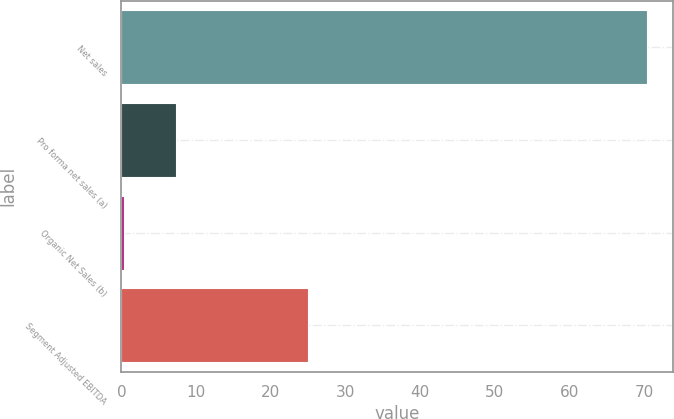Convert chart. <chart><loc_0><loc_0><loc_500><loc_500><bar_chart><fcel>Net sales<fcel>Pro forma net sales (a)<fcel>Organic Net Sales (b)<fcel>Segment Adjusted EBITDA<nl><fcel>70.3<fcel>7.3<fcel>0.3<fcel>25<nl></chart> 